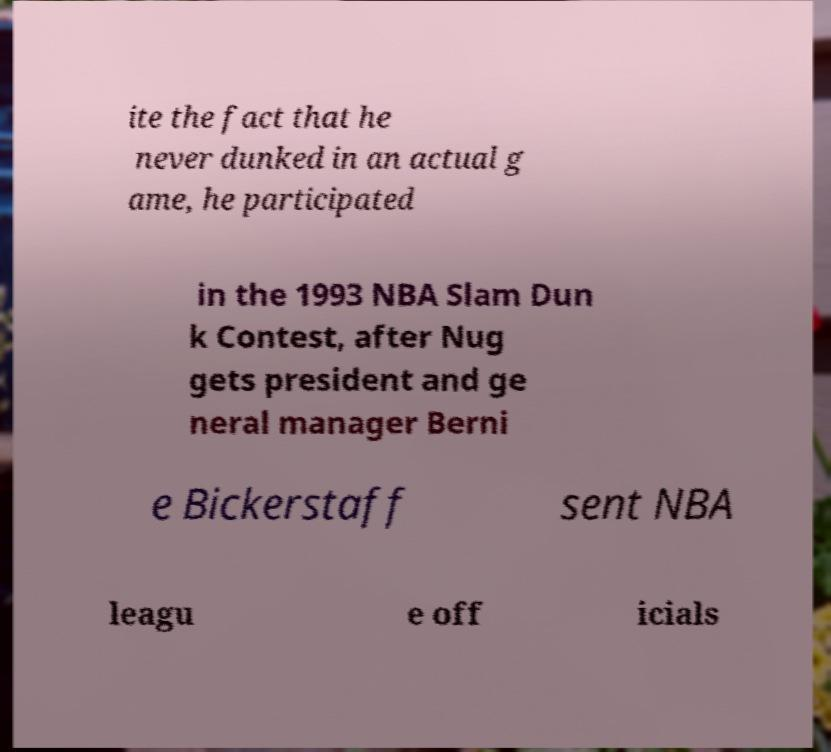For documentation purposes, I need the text within this image transcribed. Could you provide that? ite the fact that he never dunked in an actual g ame, he participated in the 1993 NBA Slam Dun k Contest, after Nug gets president and ge neral manager Berni e Bickerstaff sent NBA leagu e off icials 